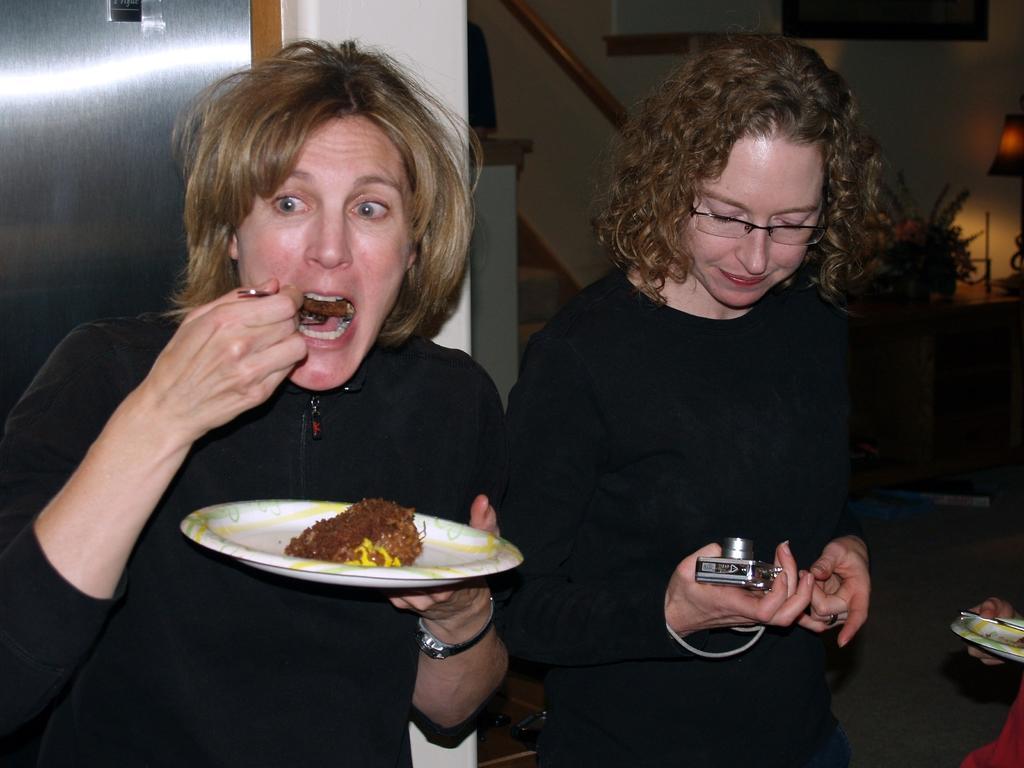Can you describe this image briefly? In this picture I can observe two women. Both of them are wearing black color dresses. One of them is holding a plate in her hand. In the background I can observe wall. 